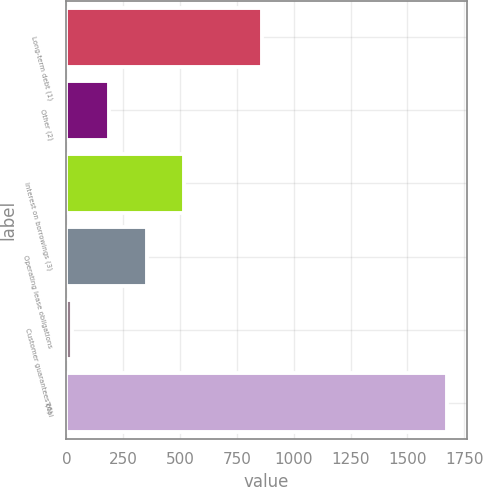Convert chart. <chart><loc_0><loc_0><loc_500><loc_500><bar_chart><fcel>Long-term debt (1)<fcel>Other (2)<fcel>Interest on borrowings (3)<fcel>Operating lease obligations<fcel>Customer guarantees (6)<fcel>Total<nl><fcel>861<fcel>189.2<fcel>519.6<fcel>354.4<fcel>24<fcel>1676<nl></chart> 